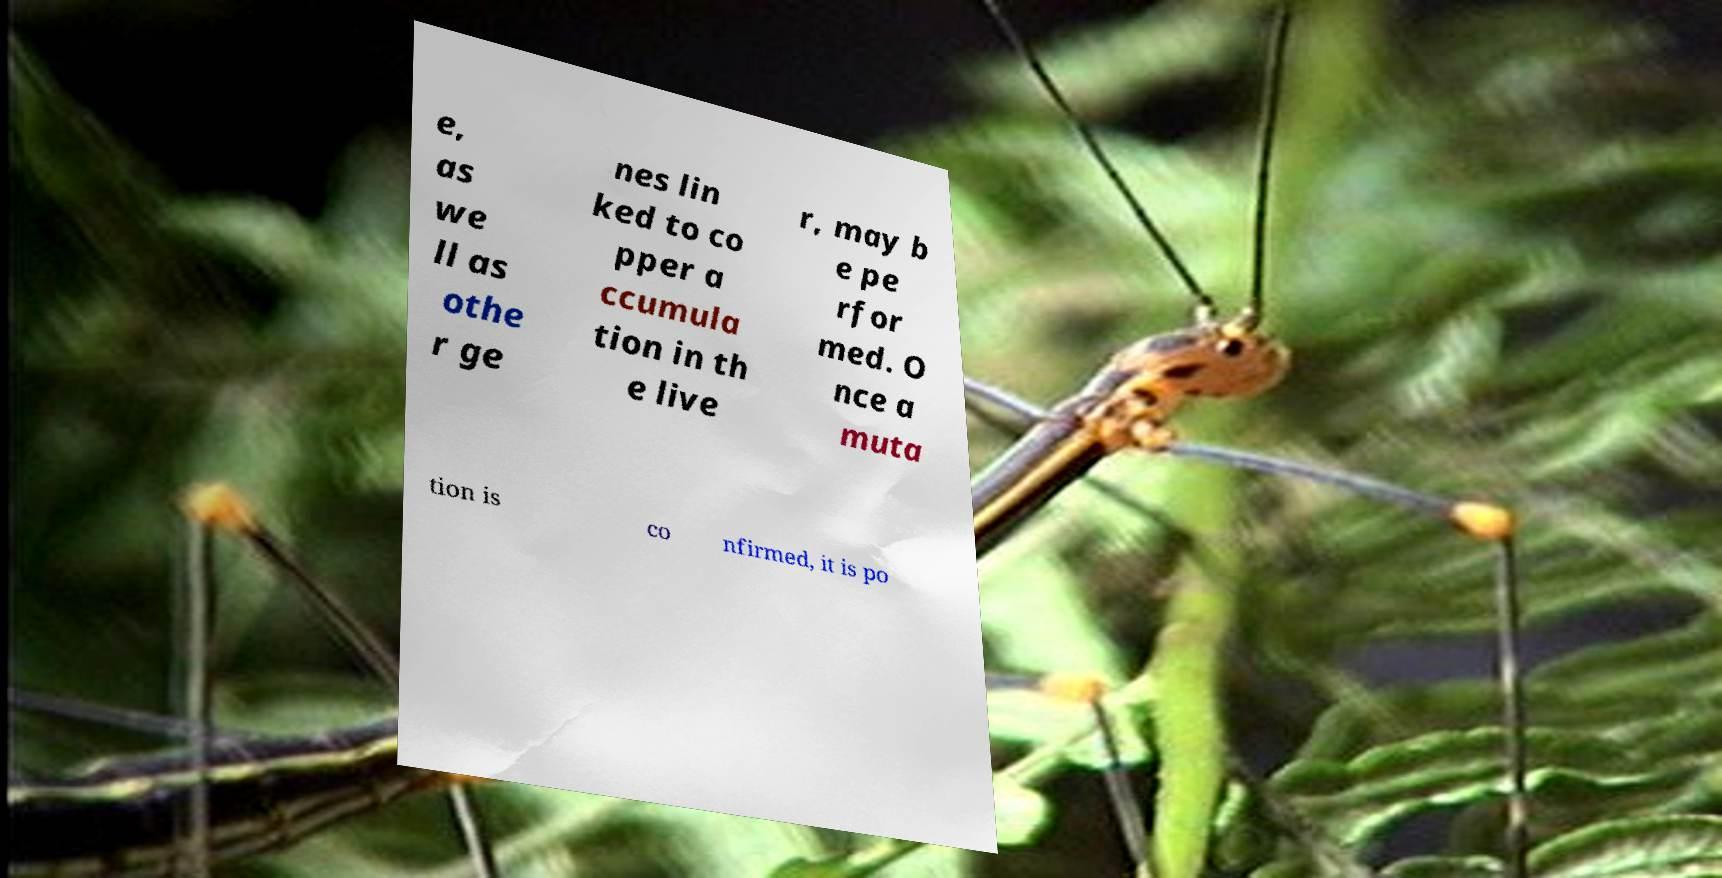What messages or text are displayed in this image? I need them in a readable, typed format. e, as we ll as othe r ge nes lin ked to co pper a ccumula tion in th e live r, may b e pe rfor med. O nce a muta tion is co nfirmed, it is po 